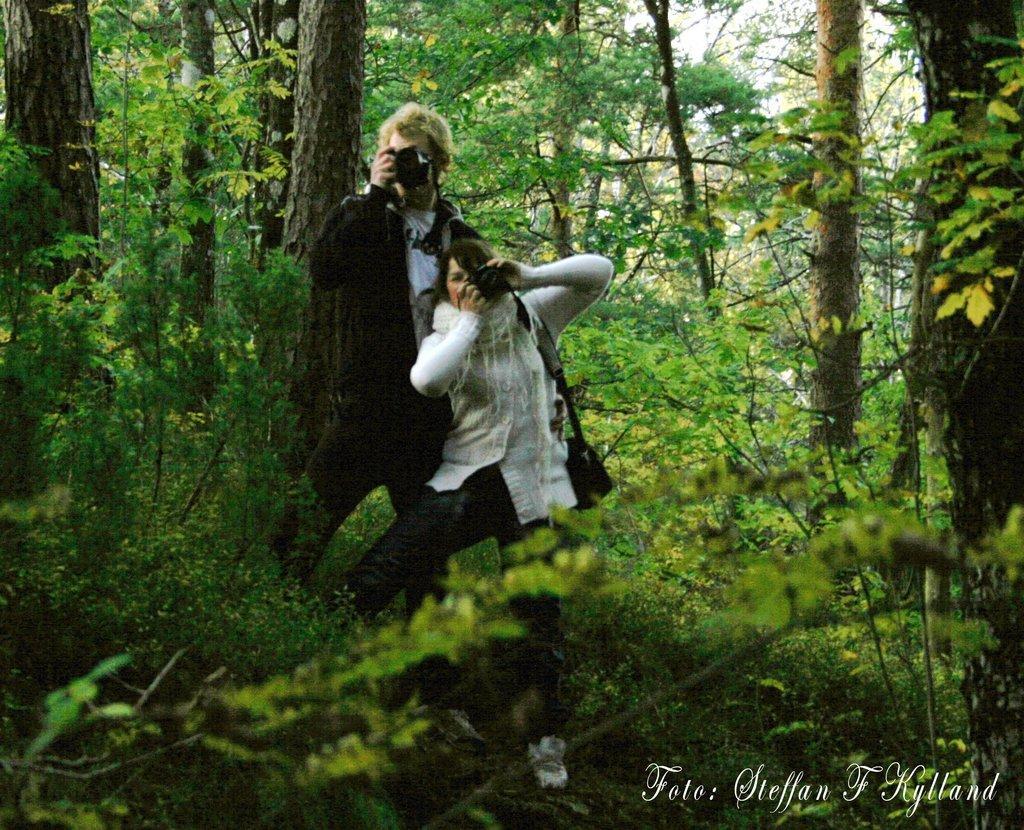In one or two sentences, can you explain what this image depicts? In this image I see a man and a woman who are holding cameras in their hands and I see that this woman is carrying a bag and I see number of trees and I see the watermark over here. 